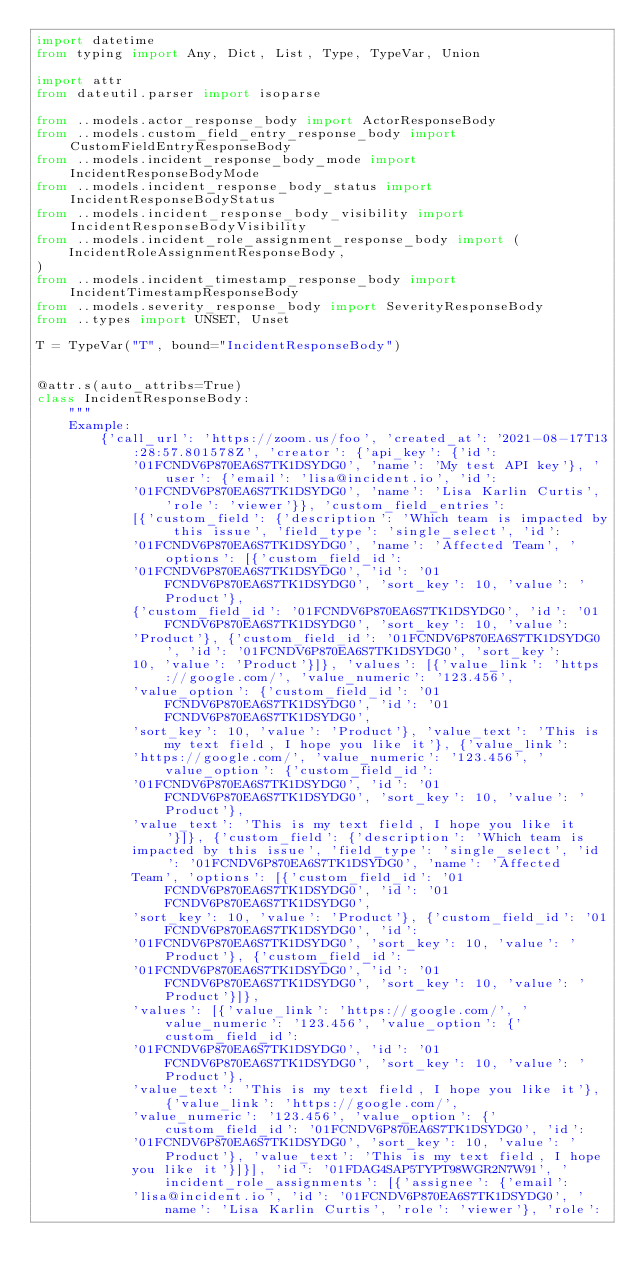<code> <loc_0><loc_0><loc_500><loc_500><_Python_>import datetime
from typing import Any, Dict, List, Type, TypeVar, Union

import attr
from dateutil.parser import isoparse

from ..models.actor_response_body import ActorResponseBody
from ..models.custom_field_entry_response_body import CustomFieldEntryResponseBody
from ..models.incident_response_body_mode import IncidentResponseBodyMode
from ..models.incident_response_body_status import IncidentResponseBodyStatus
from ..models.incident_response_body_visibility import IncidentResponseBodyVisibility
from ..models.incident_role_assignment_response_body import (
    IncidentRoleAssignmentResponseBody,
)
from ..models.incident_timestamp_response_body import IncidentTimestampResponseBody
from ..models.severity_response_body import SeverityResponseBody
from ..types import UNSET, Unset

T = TypeVar("T", bound="IncidentResponseBody")


@attr.s(auto_attribs=True)
class IncidentResponseBody:
    """
    Example:
        {'call_url': 'https://zoom.us/foo', 'created_at': '2021-08-17T13:28:57.801578Z', 'creator': {'api_key': {'id':
            '01FCNDV6P870EA6S7TK1DSYDG0', 'name': 'My test API key'}, 'user': {'email': 'lisa@incident.io', 'id':
            '01FCNDV6P870EA6S7TK1DSYDG0', 'name': 'Lisa Karlin Curtis', 'role': 'viewer'}}, 'custom_field_entries':
            [{'custom_field': {'description': 'Which team is impacted by this issue', 'field_type': 'single_select', 'id':
            '01FCNDV6P870EA6S7TK1DSYDG0', 'name': 'Affected Team', 'options': [{'custom_field_id':
            '01FCNDV6P870EA6S7TK1DSYDG0', 'id': '01FCNDV6P870EA6S7TK1DSYDG0', 'sort_key': 10, 'value': 'Product'},
            {'custom_field_id': '01FCNDV6P870EA6S7TK1DSYDG0', 'id': '01FCNDV6P870EA6S7TK1DSYDG0', 'sort_key': 10, 'value':
            'Product'}, {'custom_field_id': '01FCNDV6P870EA6S7TK1DSYDG0', 'id': '01FCNDV6P870EA6S7TK1DSYDG0', 'sort_key':
            10, 'value': 'Product'}]}, 'values': [{'value_link': 'https://google.com/', 'value_numeric': '123.456',
            'value_option': {'custom_field_id': '01FCNDV6P870EA6S7TK1DSYDG0', 'id': '01FCNDV6P870EA6S7TK1DSYDG0',
            'sort_key': 10, 'value': 'Product'}, 'value_text': 'This is my text field, I hope you like it'}, {'value_link':
            'https://google.com/', 'value_numeric': '123.456', 'value_option': {'custom_field_id':
            '01FCNDV6P870EA6S7TK1DSYDG0', 'id': '01FCNDV6P870EA6S7TK1DSYDG0', 'sort_key': 10, 'value': 'Product'},
            'value_text': 'This is my text field, I hope you like it'}]}, {'custom_field': {'description': 'Which team is
            impacted by this issue', 'field_type': 'single_select', 'id': '01FCNDV6P870EA6S7TK1DSYDG0', 'name': 'Affected
            Team', 'options': [{'custom_field_id': '01FCNDV6P870EA6S7TK1DSYDG0', 'id': '01FCNDV6P870EA6S7TK1DSYDG0',
            'sort_key': 10, 'value': 'Product'}, {'custom_field_id': '01FCNDV6P870EA6S7TK1DSYDG0', 'id':
            '01FCNDV6P870EA6S7TK1DSYDG0', 'sort_key': 10, 'value': 'Product'}, {'custom_field_id':
            '01FCNDV6P870EA6S7TK1DSYDG0', 'id': '01FCNDV6P870EA6S7TK1DSYDG0', 'sort_key': 10, 'value': 'Product'}]},
            'values': [{'value_link': 'https://google.com/', 'value_numeric': '123.456', 'value_option': {'custom_field_id':
            '01FCNDV6P870EA6S7TK1DSYDG0', 'id': '01FCNDV6P870EA6S7TK1DSYDG0', 'sort_key': 10, 'value': 'Product'},
            'value_text': 'This is my text field, I hope you like it'}, {'value_link': 'https://google.com/',
            'value_numeric': '123.456', 'value_option': {'custom_field_id': '01FCNDV6P870EA6S7TK1DSYDG0', 'id':
            '01FCNDV6P870EA6S7TK1DSYDG0', 'sort_key': 10, 'value': 'Product'}, 'value_text': 'This is my text field, I hope
            you like it'}]}], 'id': '01FDAG4SAP5TYPT98WGR2N7W91', 'incident_role_assignments': [{'assignee': {'email':
            'lisa@incident.io', 'id': '01FCNDV6P870EA6S7TK1DSYDG0', 'name': 'Lisa Karlin Curtis', 'role': 'viewer'}, 'role':</code> 